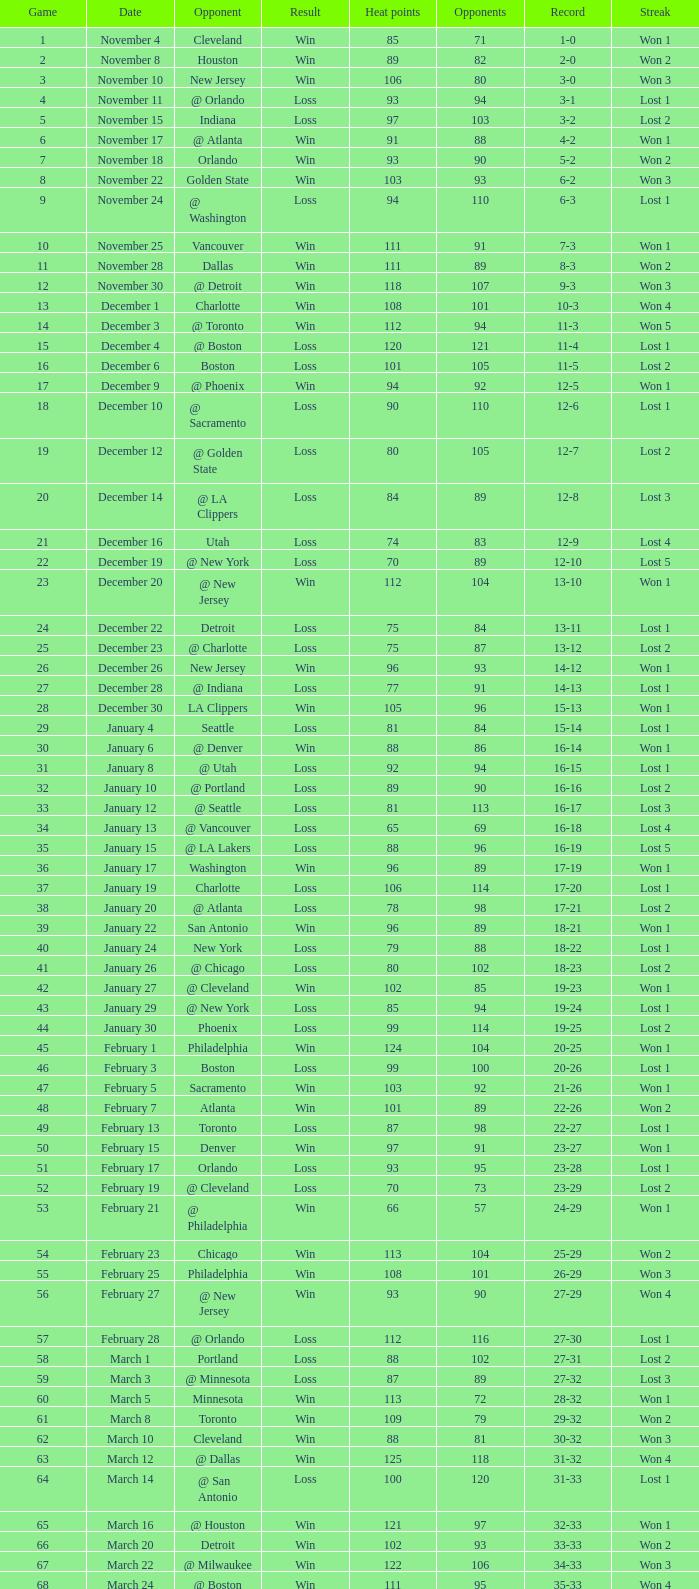What is the top game, when there are under 80 opponents, and the record is "1-0"? 1.0. 